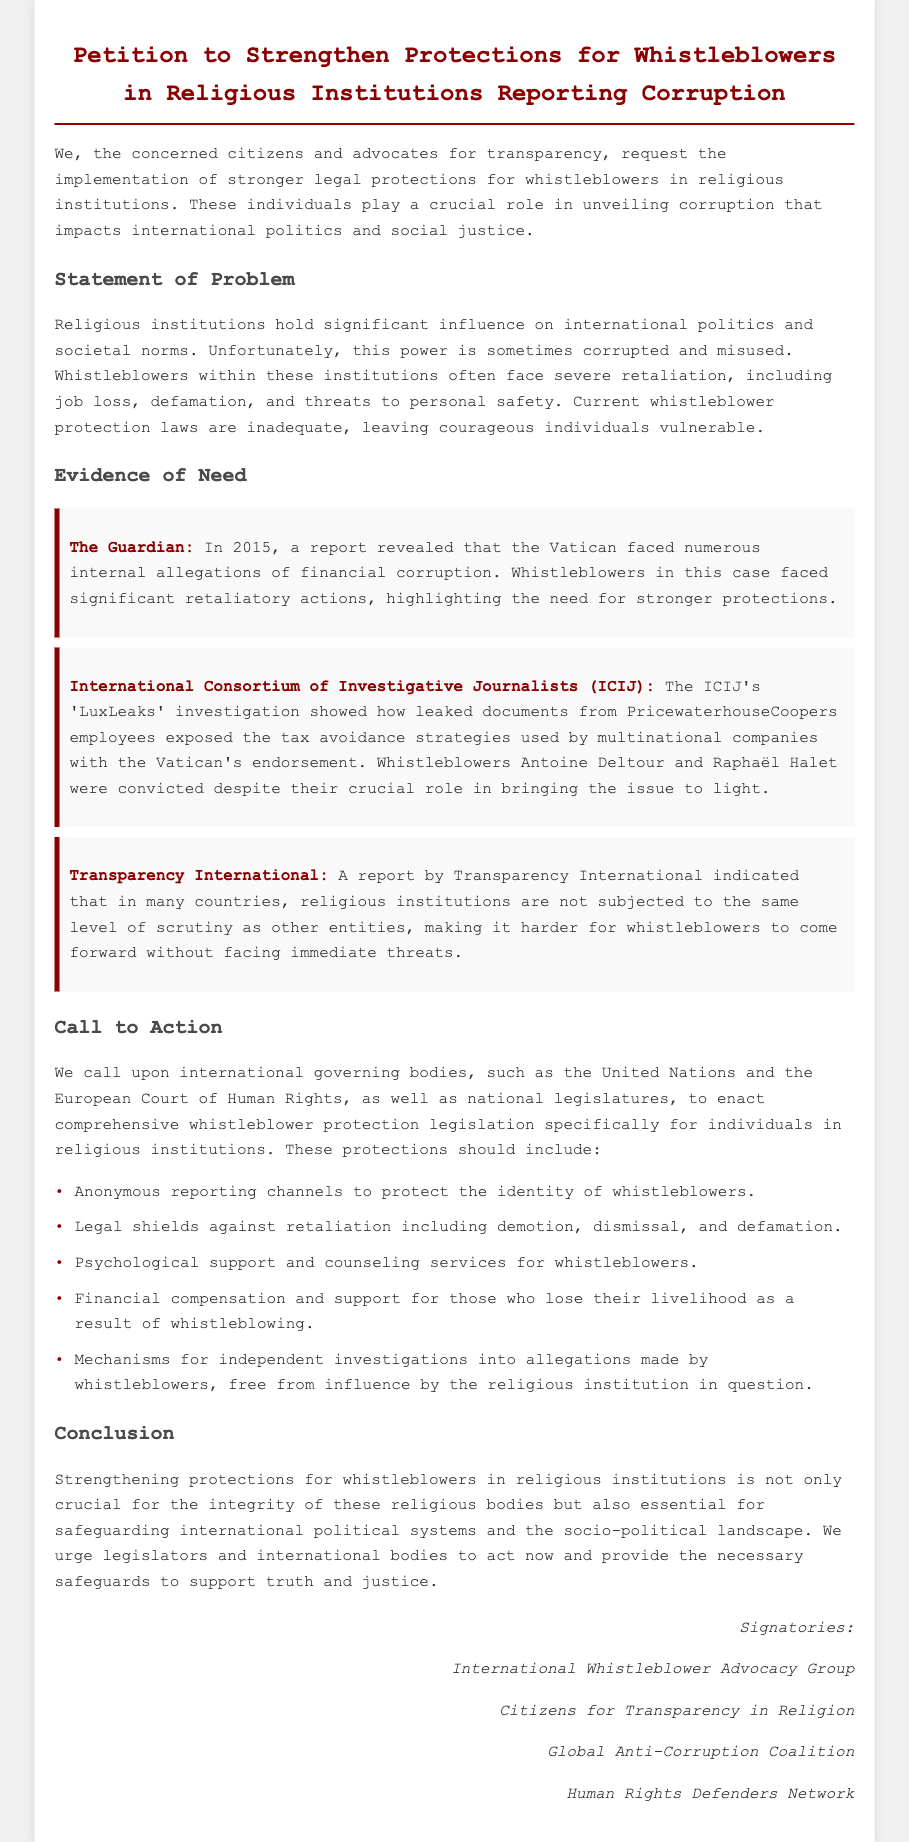what is the title of the petition? The title is a key identifier of the document and is mentioned at the top of the rendered document.
Answer: Petition to Strengthen Protections for Whistleblowers in Religious Institutions Reporting Corruption who are the signatories listed in the document? The signatories reflect the organizations supporting the petition and are mentioned at the end of the document.
Answer: International Whistleblower Advocacy Group, Citizens for Transparency in Religion, Global Anti-Corruption Coalition, Human Rights Defenders Network what year was the report about the Vatican's financial corruption published? The specific year helps to provide context for the evidence presented in the petition.
Answer: 2015 which investigative organization conducted the 'LuxLeaks' investigation? The organization is critical to understanding the sources of evidence against corrupt practices mentioned in the document.
Answer: International Consortium of Investigative Journalists (ICIJ) what types of protections are being called for in the petition? This question focuses on the specific requests made in the petition for whistleblower protections.
Answer: Anonymous reporting channels, Legal shields against retaliation, Psychological support, Financial compensation, Mechanisms for independent investigations why is strengthening whistleblower protection crucial according to the document? This inquiry invites a deeper understanding of the implications of the petition's call to action.
Answer: Integrity of religious bodies and safeguarding international political systems how many examples of evidence for the need of whistleblower protection are provided? The number of examples illustrates the extent of the problem being addressed in the petition.
Answer: Three 